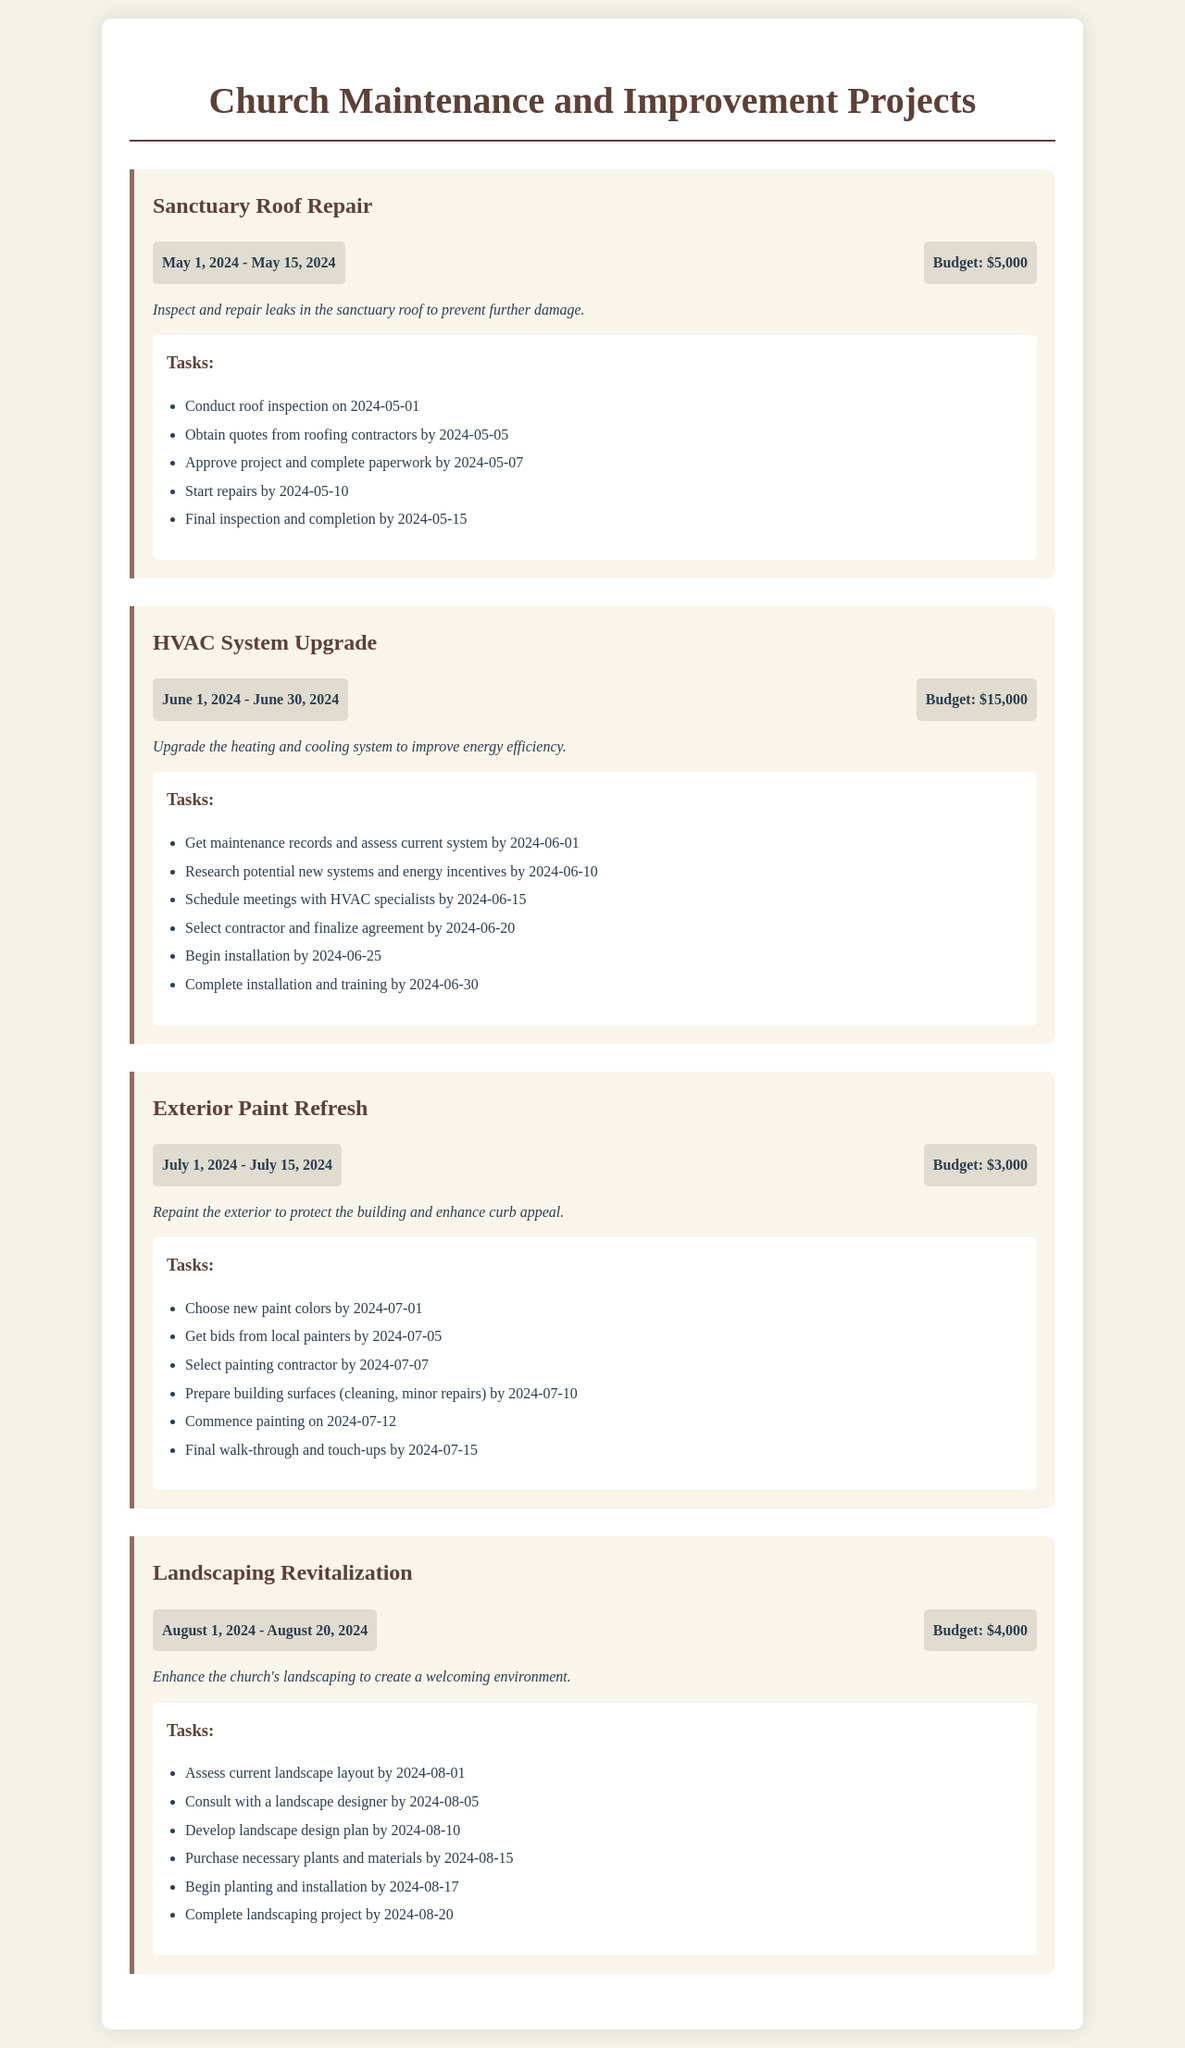What is the budget for the Sanctuary Roof Repair? The budget for the Sanctuary Roof Repair is stated in the project section, which is $5,000.
Answer: $5,000 When does the HVAC System Upgrade project start? The start date of the HVAC System Upgrade project can be found in the timeline section, which begins on June 1, 2024.
Answer: June 1, 2024 How many tasks are listed for the Exterior Paint Refresh project? The number of tasks for the Exterior Paint Refresh can be counted in the tasks section, which lists 6 tasks.
Answer: 6 What is the timeline for the Landscaping Revitalization project? The timeline for the Landscaping Revitalization project is detailed in the project info section, running from August 1, 2024 to August 20, 2024.
Answer: August 1, 2024 - August 20, 2024 Which project has the highest budget estimate? The budget comparison shows that the HVAC System Upgrade has the highest budget estimate of $15,000.
Answer: $15,000 What is the end date for the Exterior Paint Refresh? The end date is clearly indicated in the project section as July 15, 2024.
Answer: July 15, 2024 What specific task starts on July 12, 2024, for the Exterior Paint Refresh? The task listed for July 12, 2024, is to commence painting as part of the Exterior Paint Refresh.
Answer: Commence painting Which project involves consulting with a designer? The Landscaping Revitalization project involves a consultation with a landscape designer as mentioned in its tasks.
Answer: Landscaping Revitalization What is the description of the Sanctuary Roof Repair project? The description of the Sanctuary Roof Repair project outlines the purpose, stating it is to inspect and repair leaks in the sanctuary roof.
Answer: Inspect and repair leaks in the sanctuary roof to prevent further damage 